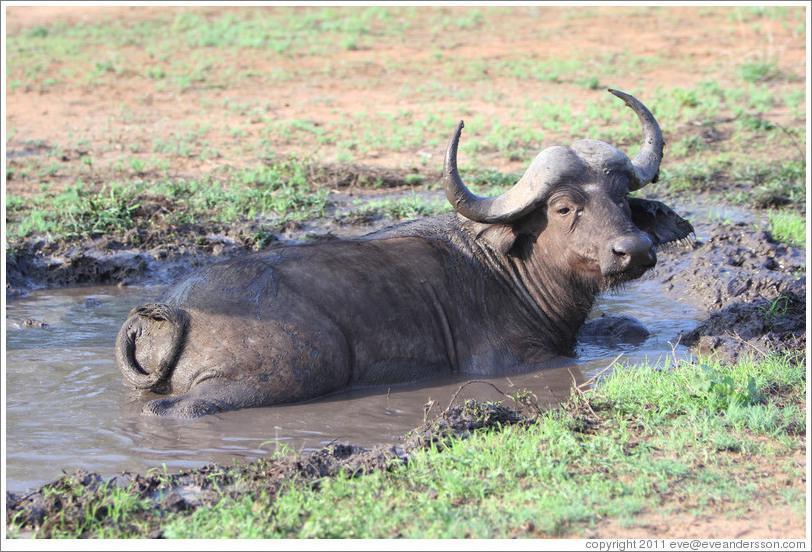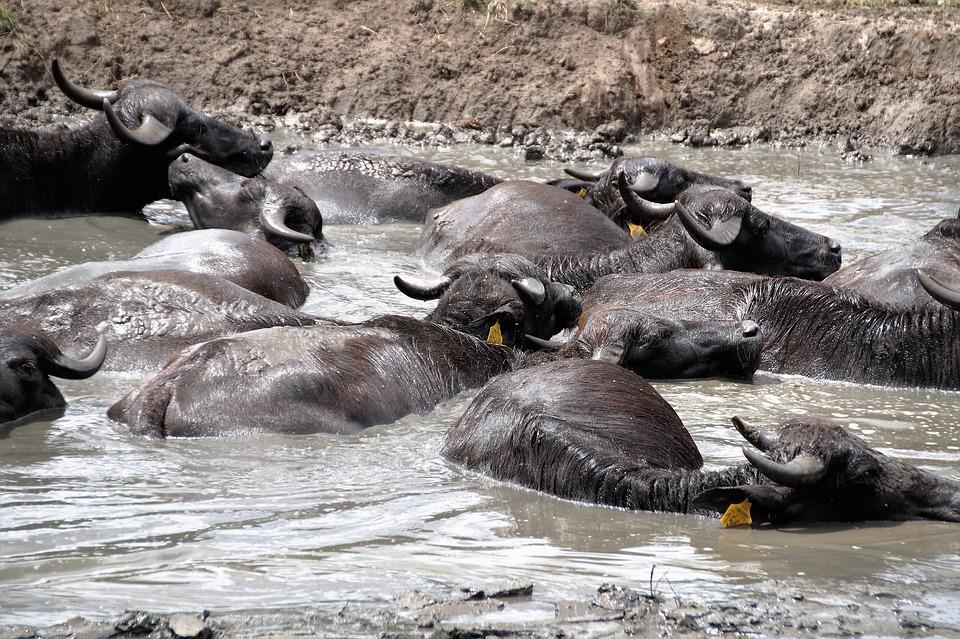The first image is the image on the left, the second image is the image on the right. Considering the images on both sides, is "The right image shows a single bull rolling on its back with legs in the air, while the left image shows a single bull wading through mud." valid? Answer yes or no. No. The first image is the image on the left, the second image is the image on the right. Assess this claim about the two images: "The right image shows one muddy water buffalo lying on its back with its hind legs extended up in the air.". Correct or not? Answer yes or no. No. 